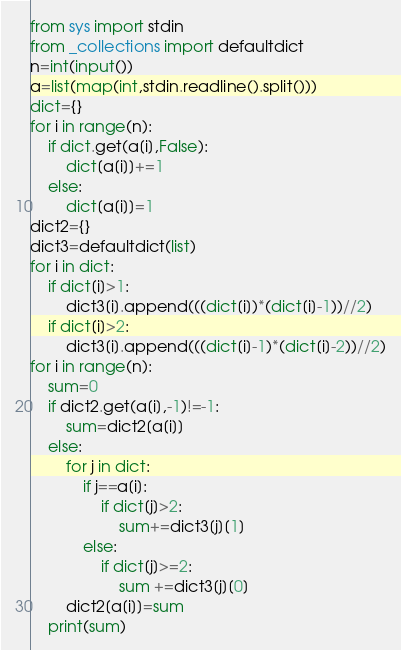<code> <loc_0><loc_0><loc_500><loc_500><_Python_>from sys import stdin
from _collections import defaultdict
n=int(input())
a=list(map(int,stdin.readline().split()))
dict={}
for i in range(n):
    if dict.get(a[i],False):
        dict[a[i]]+=1
    else:
        dict[a[i]]=1
dict2={}
dict3=defaultdict(list)
for i in dict:
    if dict[i]>1:
        dict3[i].append(((dict[i])*(dict[i]-1))//2)
    if dict[i]>2:
        dict3[i].append(((dict[i]-1)*(dict[i]-2))//2)
for i in range(n):
    sum=0
    if dict2.get(a[i],-1)!=-1:
        sum=dict2[a[i]]
    else:
        for j in dict:
            if j==a[i]:
                if dict[j]>2:
                    sum+=dict3[j][1]
            else:
                if dict[j]>=2:
                    sum +=dict3[j][0]
        dict2[a[i]]=sum
    print(sum)</code> 